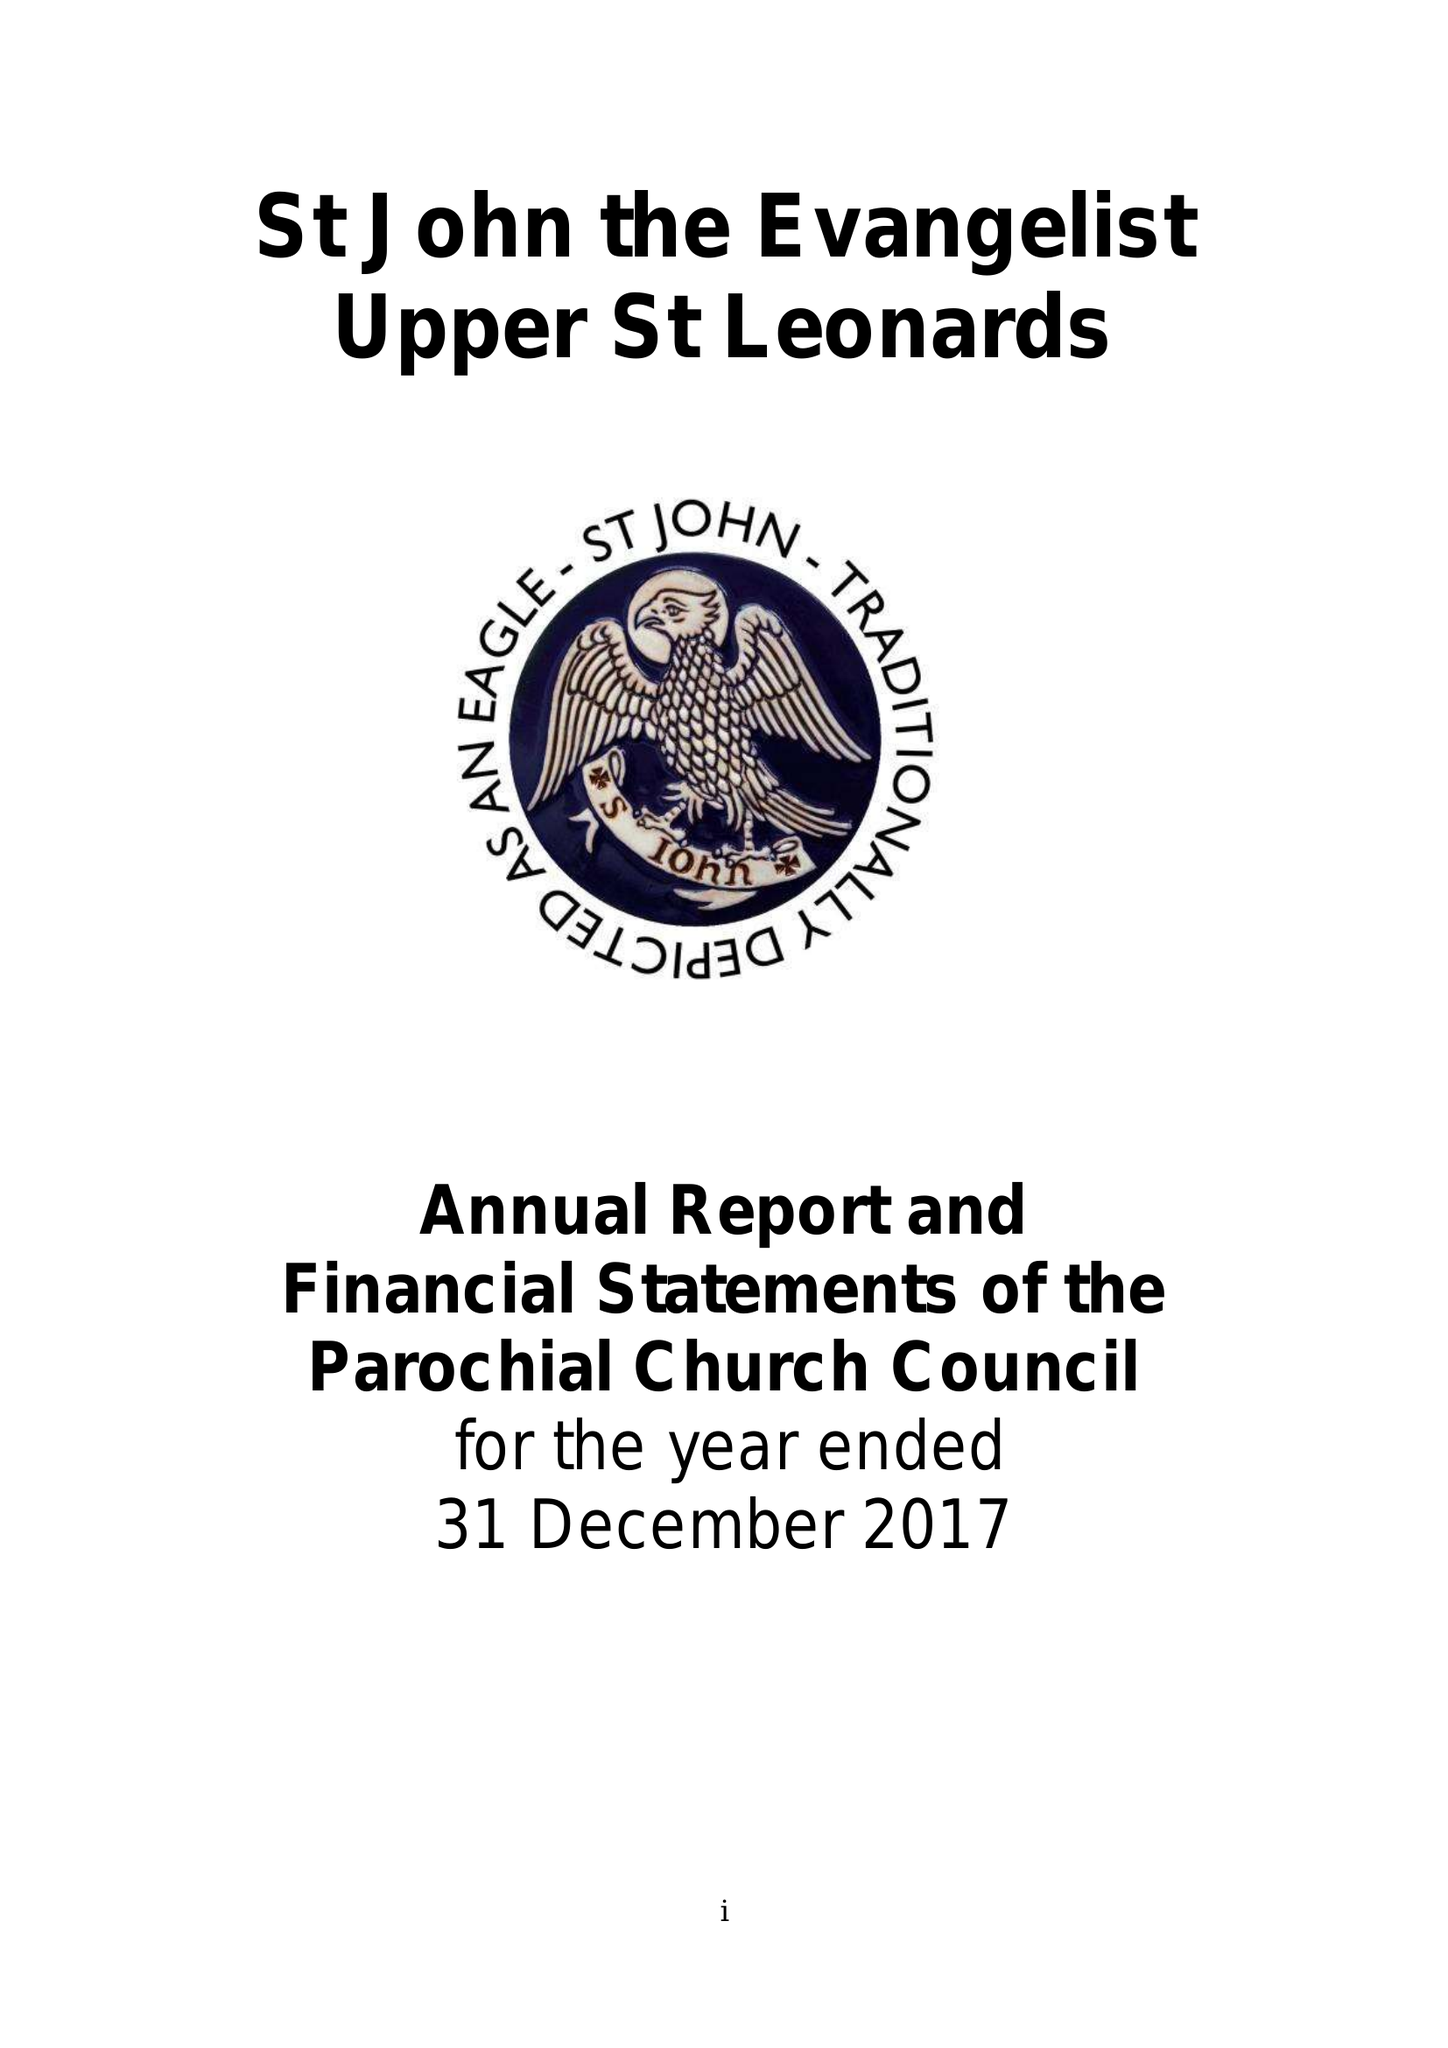What is the value for the report_date?
Answer the question using a single word or phrase. 2017-12-31 